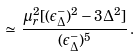<formula> <loc_0><loc_0><loc_500><loc_500>\simeq \, \frac { \mu _ { r } ^ { 2 } [ ( \epsilon ^ { - } _ { \Delta } ) ^ { 2 } - 3 \Delta ^ { 2 } ] } { ( \epsilon ^ { - } _ { \Delta } ) ^ { 5 } } \, .</formula> 